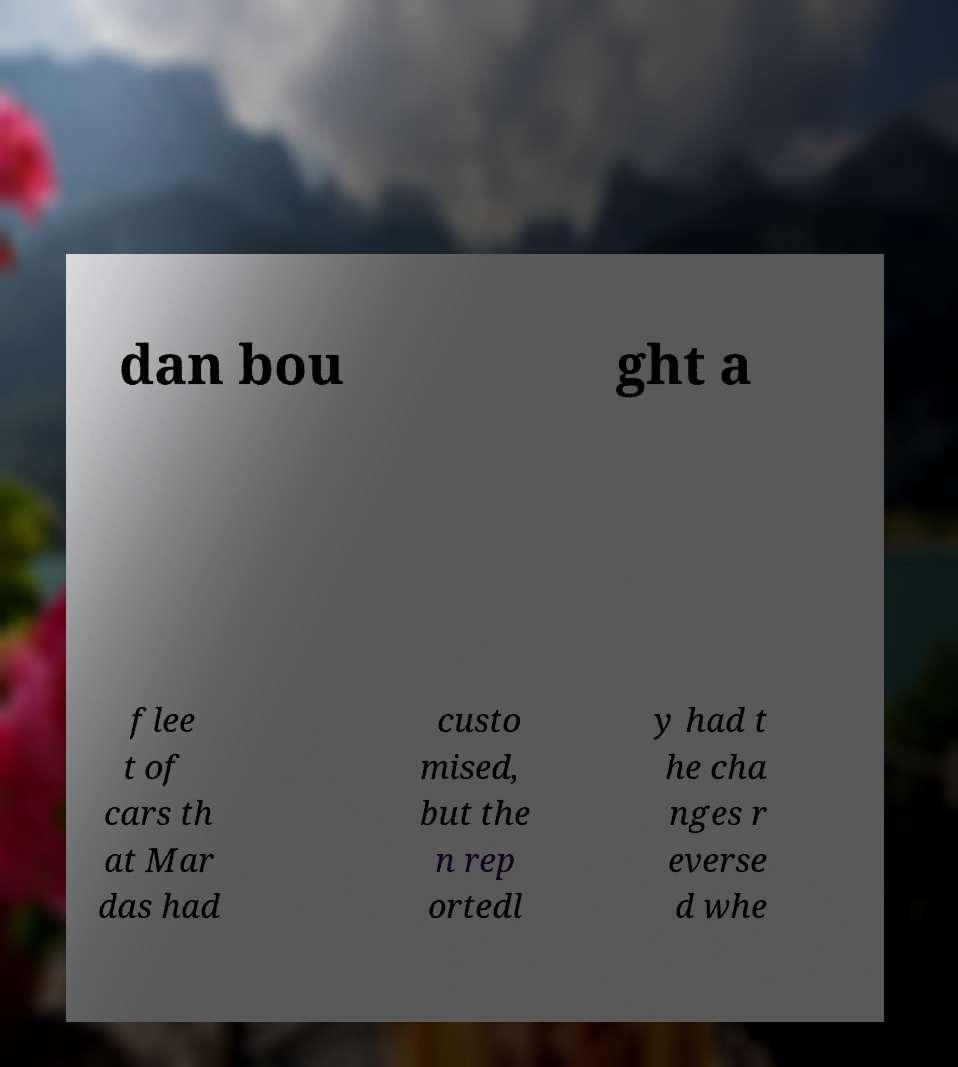Please identify and transcribe the text found in this image. dan bou ght a flee t of cars th at Mar das had custo mised, but the n rep ortedl y had t he cha nges r everse d whe 